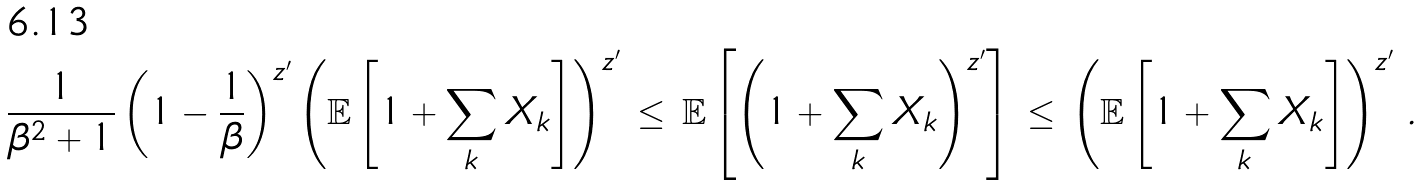Convert formula to latex. <formula><loc_0><loc_0><loc_500><loc_500>\frac { 1 } { \beta ^ { 2 } + 1 } \left ( 1 - \frac { 1 } { \beta } \right ) ^ { z ^ { \prime } } \left ( \mathbb { E } \left [ 1 + \sum _ { k } X _ { k } \right ] \right ) ^ { z ^ { \prime } } \, \leq \, \mathbb { E } \left [ \left ( 1 + \sum _ { k } X _ { k } \right ) ^ { z ^ { \prime } } \right ] \, \leq \, \left ( \mathbb { E } \left [ 1 + \sum _ { k } X _ { k } \right ] \right ) ^ { z ^ { \prime } } \, .</formula> 